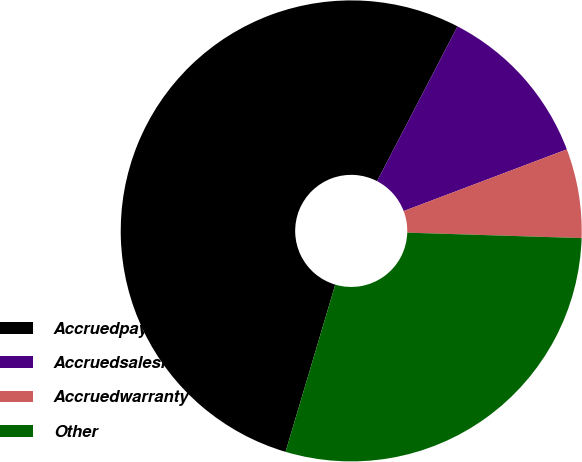Convert chart. <chart><loc_0><loc_0><loc_500><loc_500><pie_chart><fcel>Accruedpayrollandbenefits<fcel>Accruedsalesrebate<fcel>Accruedwarranty<fcel>Other<nl><fcel>53.03%<fcel>11.62%<fcel>6.25%<fcel>29.1%<nl></chart> 